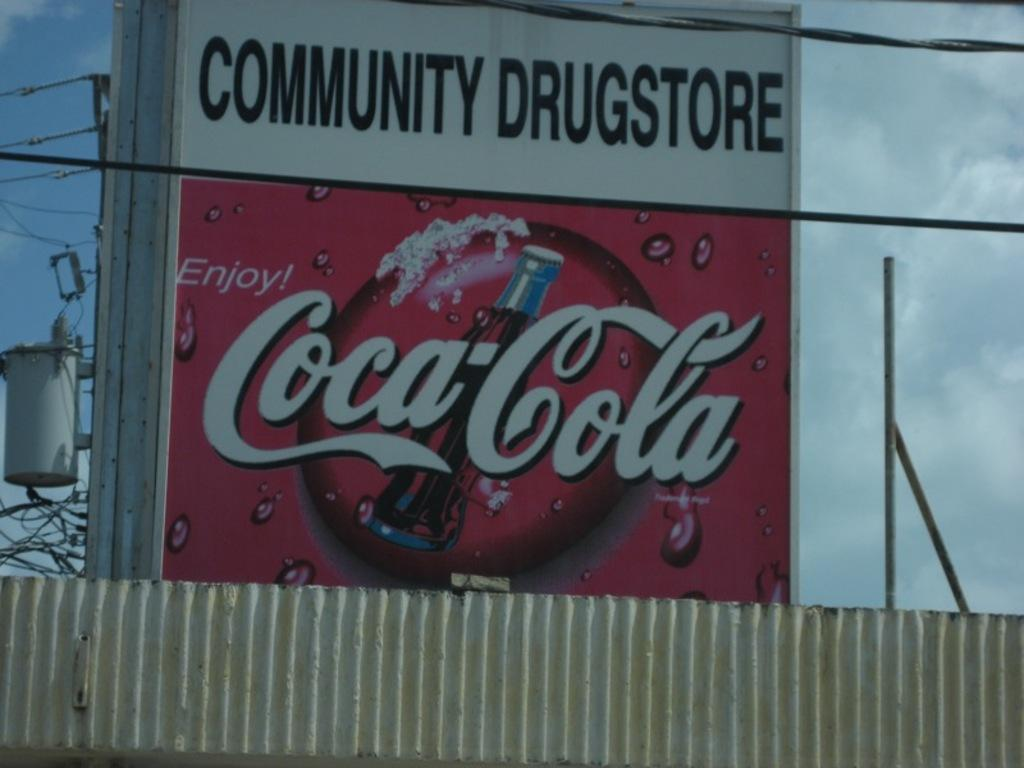What is written or displayed on the board in the image? There is a board with text in the image. What type of structure is at the bottom of the image? There is a wall at the bottom of the image. What can be seen in the background of the image? Wires and the sky are visible in the background of the image. How many oranges are on the desk in the image? There is no desk or oranges present in the image. What time of day is depicted in the image? The time of day cannot be determined from the image, as there are no specific indicators of morning or any other time. 